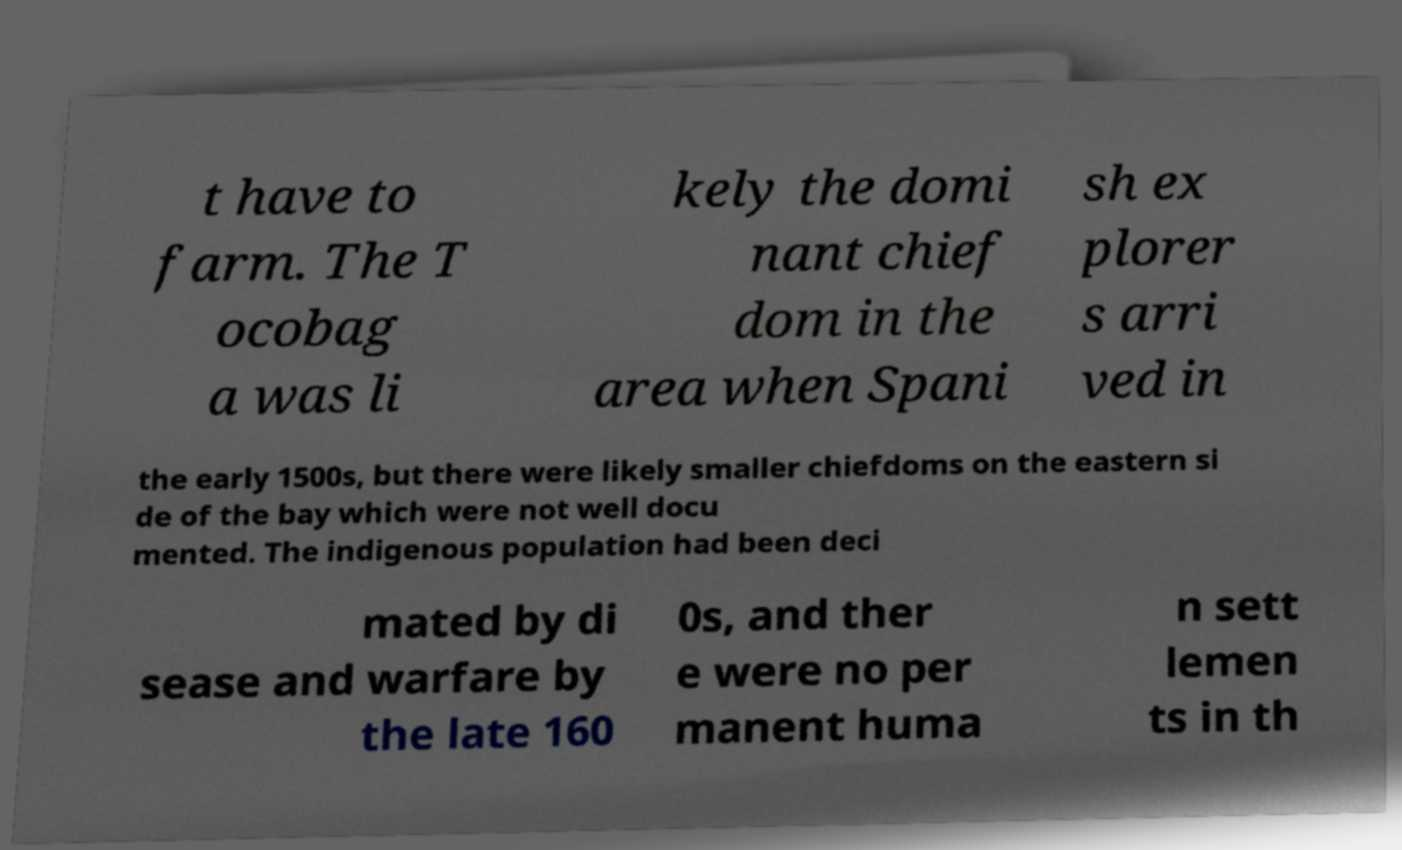What messages or text are displayed in this image? I need them in a readable, typed format. t have to farm. The T ocobag a was li kely the domi nant chief dom in the area when Spani sh ex plorer s arri ved in the early 1500s, but there were likely smaller chiefdoms on the eastern si de of the bay which were not well docu mented. The indigenous population had been deci mated by di sease and warfare by the late 160 0s, and ther e were no per manent huma n sett lemen ts in th 